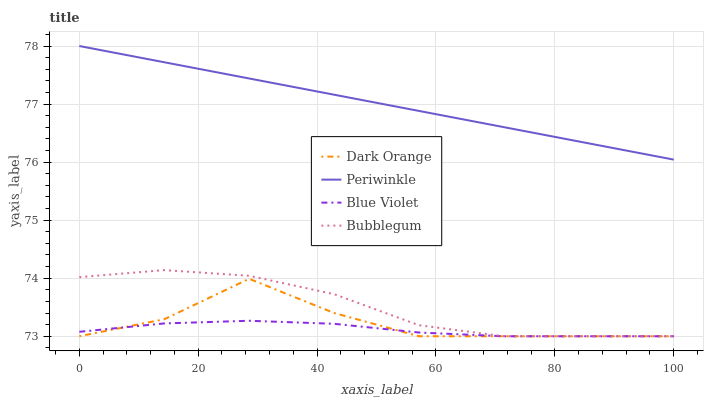Does Bubblegum have the minimum area under the curve?
Answer yes or no. No. Does Bubblegum have the maximum area under the curve?
Answer yes or no. No. Is Bubblegum the smoothest?
Answer yes or no. No. Is Bubblegum the roughest?
Answer yes or no. No. Does Periwinkle have the lowest value?
Answer yes or no. No. Does Bubblegum have the highest value?
Answer yes or no. No. Is Dark Orange less than Periwinkle?
Answer yes or no. Yes. Is Periwinkle greater than Bubblegum?
Answer yes or no. Yes. Does Dark Orange intersect Periwinkle?
Answer yes or no. No. 